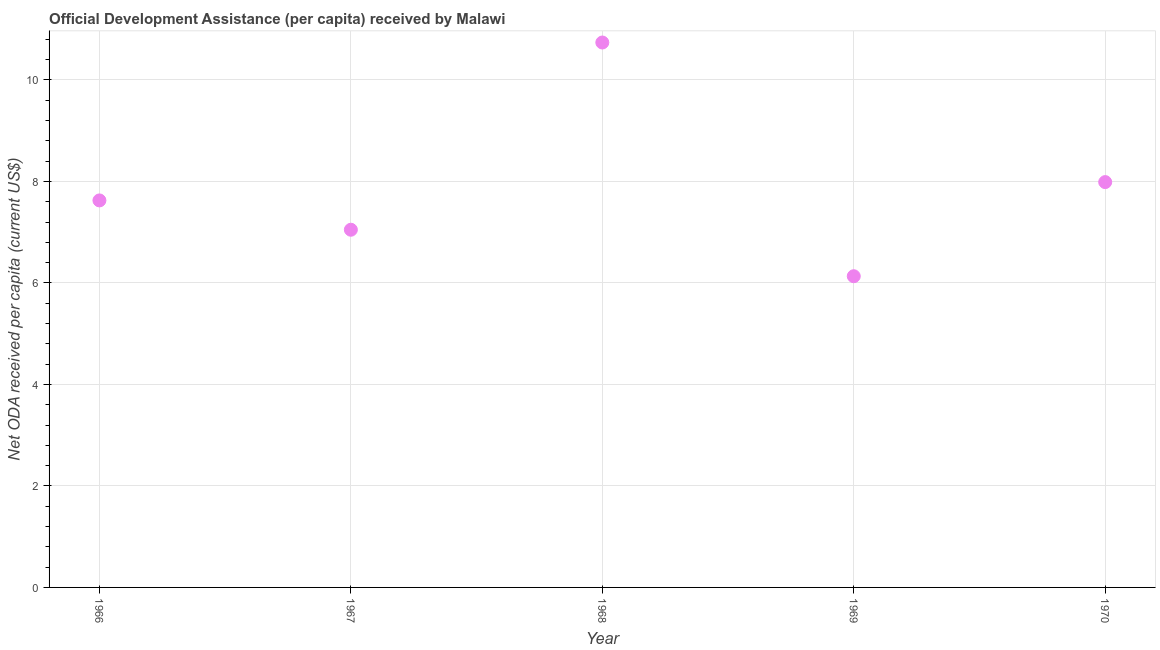What is the net oda received per capita in 1966?
Your answer should be very brief. 7.63. Across all years, what is the maximum net oda received per capita?
Provide a succinct answer. 10.74. Across all years, what is the minimum net oda received per capita?
Give a very brief answer. 6.13. In which year was the net oda received per capita maximum?
Offer a very short reply. 1968. In which year was the net oda received per capita minimum?
Keep it short and to the point. 1969. What is the sum of the net oda received per capita?
Your response must be concise. 39.53. What is the difference between the net oda received per capita in 1966 and 1969?
Give a very brief answer. 1.49. What is the average net oda received per capita per year?
Keep it short and to the point. 7.91. What is the median net oda received per capita?
Provide a short and direct response. 7.63. Do a majority of the years between 1969 and 1970 (inclusive) have net oda received per capita greater than 5.2 US$?
Your answer should be very brief. Yes. What is the ratio of the net oda received per capita in 1967 to that in 1970?
Offer a terse response. 0.88. Is the net oda received per capita in 1966 less than that in 1970?
Offer a terse response. Yes. Is the difference between the net oda received per capita in 1968 and 1969 greater than the difference between any two years?
Provide a succinct answer. Yes. What is the difference between the highest and the second highest net oda received per capita?
Keep it short and to the point. 2.75. Is the sum of the net oda received per capita in 1967 and 1970 greater than the maximum net oda received per capita across all years?
Provide a succinct answer. Yes. What is the difference between the highest and the lowest net oda received per capita?
Make the answer very short. 4.61. In how many years, is the net oda received per capita greater than the average net oda received per capita taken over all years?
Your response must be concise. 2. Are the values on the major ticks of Y-axis written in scientific E-notation?
Provide a short and direct response. No. Does the graph contain grids?
Offer a very short reply. Yes. What is the title of the graph?
Your response must be concise. Official Development Assistance (per capita) received by Malawi. What is the label or title of the X-axis?
Keep it short and to the point. Year. What is the label or title of the Y-axis?
Offer a very short reply. Net ODA received per capita (current US$). What is the Net ODA received per capita (current US$) in 1966?
Your answer should be very brief. 7.63. What is the Net ODA received per capita (current US$) in 1967?
Keep it short and to the point. 7.05. What is the Net ODA received per capita (current US$) in 1968?
Keep it short and to the point. 10.74. What is the Net ODA received per capita (current US$) in 1969?
Keep it short and to the point. 6.13. What is the Net ODA received per capita (current US$) in 1970?
Your answer should be compact. 7.99. What is the difference between the Net ODA received per capita (current US$) in 1966 and 1967?
Keep it short and to the point. 0.58. What is the difference between the Net ODA received per capita (current US$) in 1966 and 1968?
Make the answer very short. -3.11. What is the difference between the Net ODA received per capita (current US$) in 1966 and 1969?
Make the answer very short. 1.49. What is the difference between the Net ODA received per capita (current US$) in 1966 and 1970?
Make the answer very short. -0.36. What is the difference between the Net ODA received per capita (current US$) in 1967 and 1968?
Your answer should be very brief. -3.69. What is the difference between the Net ODA received per capita (current US$) in 1967 and 1969?
Give a very brief answer. 0.92. What is the difference between the Net ODA received per capita (current US$) in 1967 and 1970?
Ensure brevity in your answer.  -0.94. What is the difference between the Net ODA received per capita (current US$) in 1968 and 1969?
Ensure brevity in your answer.  4.61. What is the difference between the Net ODA received per capita (current US$) in 1968 and 1970?
Ensure brevity in your answer.  2.75. What is the difference between the Net ODA received per capita (current US$) in 1969 and 1970?
Your answer should be compact. -1.85. What is the ratio of the Net ODA received per capita (current US$) in 1966 to that in 1967?
Make the answer very short. 1.08. What is the ratio of the Net ODA received per capita (current US$) in 1966 to that in 1968?
Keep it short and to the point. 0.71. What is the ratio of the Net ODA received per capita (current US$) in 1966 to that in 1969?
Offer a very short reply. 1.24. What is the ratio of the Net ODA received per capita (current US$) in 1966 to that in 1970?
Offer a terse response. 0.95. What is the ratio of the Net ODA received per capita (current US$) in 1967 to that in 1968?
Make the answer very short. 0.66. What is the ratio of the Net ODA received per capita (current US$) in 1967 to that in 1969?
Offer a very short reply. 1.15. What is the ratio of the Net ODA received per capita (current US$) in 1967 to that in 1970?
Your response must be concise. 0.88. What is the ratio of the Net ODA received per capita (current US$) in 1968 to that in 1969?
Your response must be concise. 1.75. What is the ratio of the Net ODA received per capita (current US$) in 1968 to that in 1970?
Keep it short and to the point. 1.34. What is the ratio of the Net ODA received per capita (current US$) in 1969 to that in 1970?
Your response must be concise. 0.77. 